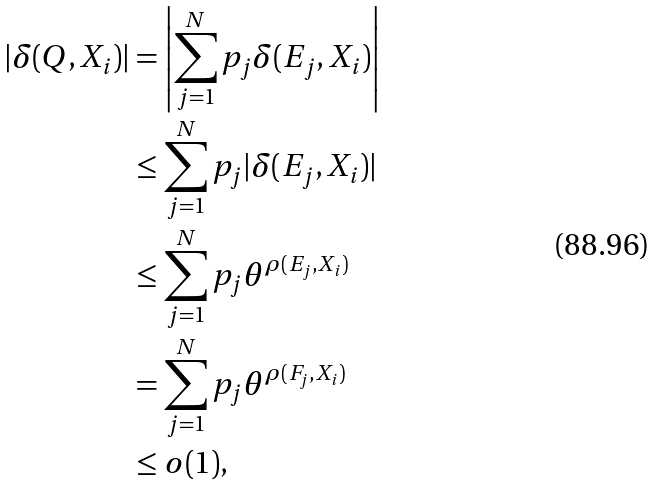<formula> <loc_0><loc_0><loc_500><loc_500>\left | \delta ( Q , X _ { i } ) \right | & = \left | \sum _ { j = 1 } ^ { N } { p _ { j } \delta ( E _ { j } , X _ { i } ) } \right | \\ & \leq \sum _ { j = 1 } ^ { N } { p _ { j } | \delta ( E _ { j } , X _ { i } ) | } \\ & \leq \sum _ { j = 1 } ^ { N } { p _ { j } \theta ^ { \rho ( E _ { j } , X _ { i } ) } } \\ & = \sum _ { j = 1 } ^ { N } { p _ { j } \theta ^ { \rho ( F _ { j } , X _ { i } ) } } \\ & \leq o ( 1 ) ,</formula> 